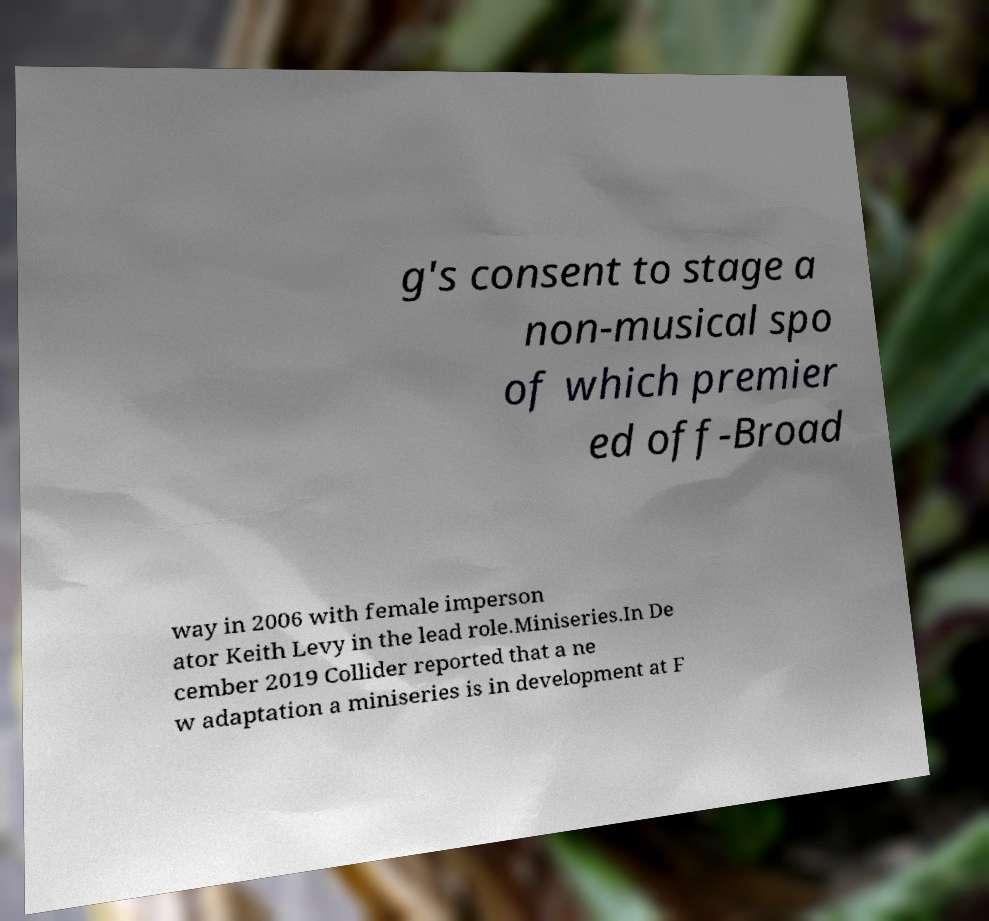Please identify and transcribe the text found in this image. g's consent to stage a non-musical spo of which premier ed off-Broad way in 2006 with female imperson ator Keith Levy in the lead role.Miniseries.In De cember 2019 Collider reported that a ne w adaptation a miniseries is in development at F 